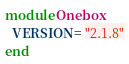<code> <loc_0><loc_0><loc_500><loc_500><_Ruby_>module Onebox
  VERSION = "2.1.8"
end
</code> 